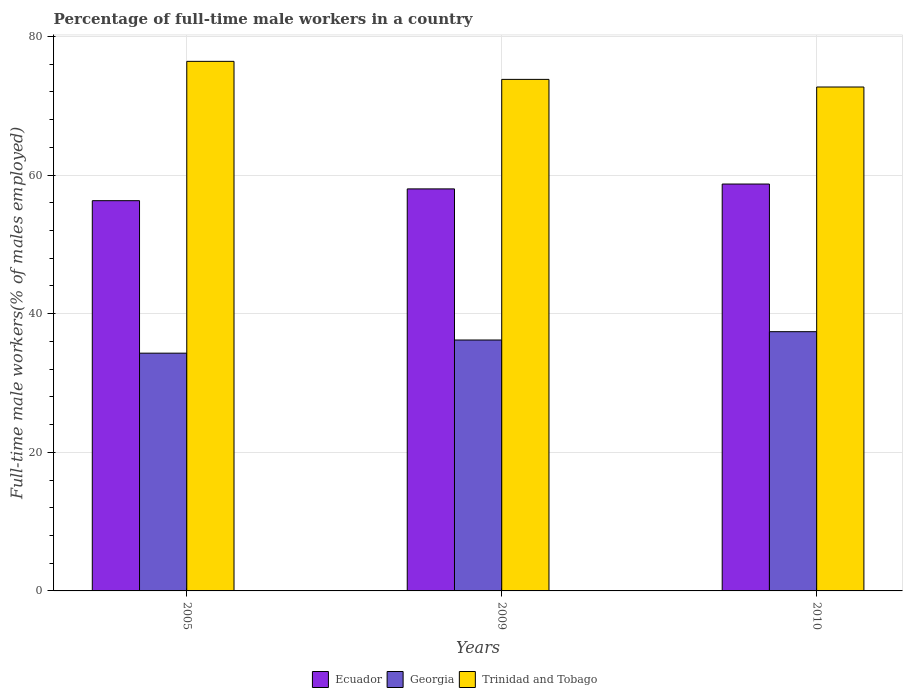How many groups of bars are there?
Your response must be concise. 3. Are the number of bars per tick equal to the number of legend labels?
Your answer should be compact. Yes. Are the number of bars on each tick of the X-axis equal?
Provide a succinct answer. Yes. In how many cases, is the number of bars for a given year not equal to the number of legend labels?
Your answer should be compact. 0. What is the percentage of full-time male workers in Trinidad and Tobago in 2009?
Provide a short and direct response. 73.8. Across all years, what is the maximum percentage of full-time male workers in Georgia?
Keep it short and to the point. 37.4. Across all years, what is the minimum percentage of full-time male workers in Trinidad and Tobago?
Your response must be concise. 72.7. In which year was the percentage of full-time male workers in Georgia minimum?
Your answer should be compact. 2005. What is the total percentage of full-time male workers in Ecuador in the graph?
Provide a short and direct response. 173. What is the difference between the percentage of full-time male workers in Trinidad and Tobago in 2009 and that in 2010?
Your answer should be compact. 1.1. What is the difference between the percentage of full-time male workers in Georgia in 2005 and the percentage of full-time male workers in Trinidad and Tobago in 2009?
Your answer should be very brief. -39.5. What is the average percentage of full-time male workers in Ecuador per year?
Offer a terse response. 57.67. In the year 2009, what is the difference between the percentage of full-time male workers in Trinidad and Tobago and percentage of full-time male workers in Georgia?
Provide a short and direct response. 37.6. What is the ratio of the percentage of full-time male workers in Georgia in 2005 to that in 2010?
Your answer should be compact. 0.92. Is the percentage of full-time male workers in Trinidad and Tobago in 2005 less than that in 2009?
Keep it short and to the point. No. Is the difference between the percentage of full-time male workers in Trinidad and Tobago in 2005 and 2009 greater than the difference between the percentage of full-time male workers in Georgia in 2005 and 2009?
Provide a short and direct response. Yes. What is the difference between the highest and the second highest percentage of full-time male workers in Ecuador?
Give a very brief answer. 0.7. What is the difference between the highest and the lowest percentage of full-time male workers in Georgia?
Keep it short and to the point. 3.1. What does the 2nd bar from the left in 2009 represents?
Make the answer very short. Georgia. What does the 1st bar from the right in 2010 represents?
Offer a terse response. Trinidad and Tobago. Is it the case that in every year, the sum of the percentage of full-time male workers in Trinidad and Tobago and percentage of full-time male workers in Ecuador is greater than the percentage of full-time male workers in Georgia?
Keep it short and to the point. Yes. Are the values on the major ticks of Y-axis written in scientific E-notation?
Give a very brief answer. No. Does the graph contain any zero values?
Provide a succinct answer. No. Does the graph contain grids?
Your response must be concise. Yes. Where does the legend appear in the graph?
Offer a very short reply. Bottom center. How many legend labels are there?
Make the answer very short. 3. What is the title of the graph?
Give a very brief answer. Percentage of full-time male workers in a country. What is the label or title of the Y-axis?
Offer a terse response. Full-time male workers(% of males employed). What is the Full-time male workers(% of males employed) of Ecuador in 2005?
Provide a short and direct response. 56.3. What is the Full-time male workers(% of males employed) in Georgia in 2005?
Offer a terse response. 34.3. What is the Full-time male workers(% of males employed) of Trinidad and Tobago in 2005?
Make the answer very short. 76.4. What is the Full-time male workers(% of males employed) of Georgia in 2009?
Your answer should be very brief. 36.2. What is the Full-time male workers(% of males employed) of Trinidad and Tobago in 2009?
Give a very brief answer. 73.8. What is the Full-time male workers(% of males employed) in Ecuador in 2010?
Your answer should be compact. 58.7. What is the Full-time male workers(% of males employed) in Georgia in 2010?
Your answer should be very brief. 37.4. What is the Full-time male workers(% of males employed) in Trinidad and Tobago in 2010?
Provide a short and direct response. 72.7. Across all years, what is the maximum Full-time male workers(% of males employed) in Ecuador?
Ensure brevity in your answer.  58.7. Across all years, what is the maximum Full-time male workers(% of males employed) of Georgia?
Offer a very short reply. 37.4. Across all years, what is the maximum Full-time male workers(% of males employed) in Trinidad and Tobago?
Provide a succinct answer. 76.4. Across all years, what is the minimum Full-time male workers(% of males employed) of Ecuador?
Offer a terse response. 56.3. Across all years, what is the minimum Full-time male workers(% of males employed) in Georgia?
Keep it short and to the point. 34.3. Across all years, what is the minimum Full-time male workers(% of males employed) in Trinidad and Tobago?
Give a very brief answer. 72.7. What is the total Full-time male workers(% of males employed) in Ecuador in the graph?
Offer a very short reply. 173. What is the total Full-time male workers(% of males employed) of Georgia in the graph?
Ensure brevity in your answer.  107.9. What is the total Full-time male workers(% of males employed) in Trinidad and Tobago in the graph?
Provide a short and direct response. 222.9. What is the difference between the Full-time male workers(% of males employed) of Ecuador in 2005 and that in 2009?
Keep it short and to the point. -1.7. What is the difference between the Full-time male workers(% of males employed) in Ecuador in 2005 and that in 2010?
Your answer should be compact. -2.4. What is the difference between the Full-time male workers(% of males employed) in Trinidad and Tobago in 2005 and that in 2010?
Offer a terse response. 3.7. What is the difference between the Full-time male workers(% of males employed) of Trinidad and Tobago in 2009 and that in 2010?
Give a very brief answer. 1.1. What is the difference between the Full-time male workers(% of males employed) in Ecuador in 2005 and the Full-time male workers(% of males employed) in Georgia in 2009?
Keep it short and to the point. 20.1. What is the difference between the Full-time male workers(% of males employed) in Ecuador in 2005 and the Full-time male workers(% of males employed) in Trinidad and Tobago in 2009?
Your answer should be very brief. -17.5. What is the difference between the Full-time male workers(% of males employed) of Georgia in 2005 and the Full-time male workers(% of males employed) of Trinidad and Tobago in 2009?
Your answer should be compact. -39.5. What is the difference between the Full-time male workers(% of males employed) in Ecuador in 2005 and the Full-time male workers(% of males employed) in Trinidad and Tobago in 2010?
Provide a short and direct response. -16.4. What is the difference between the Full-time male workers(% of males employed) in Georgia in 2005 and the Full-time male workers(% of males employed) in Trinidad and Tobago in 2010?
Ensure brevity in your answer.  -38.4. What is the difference between the Full-time male workers(% of males employed) of Ecuador in 2009 and the Full-time male workers(% of males employed) of Georgia in 2010?
Your response must be concise. 20.6. What is the difference between the Full-time male workers(% of males employed) of Ecuador in 2009 and the Full-time male workers(% of males employed) of Trinidad and Tobago in 2010?
Offer a terse response. -14.7. What is the difference between the Full-time male workers(% of males employed) of Georgia in 2009 and the Full-time male workers(% of males employed) of Trinidad and Tobago in 2010?
Your response must be concise. -36.5. What is the average Full-time male workers(% of males employed) of Ecuador per year?
Your answer should be compact. 57.67. What is the average Full-time male workers(% of males employed) of Georgia per year?
Give a very brief answer. 35.97. What is the average Full-time male workers(% of males employed) of Trinidad and Tobago per year?
Your answer should be very brief. 74.3. In the year 2005, what is the difference between the Full-time male workers(% of males employed) of Ecuador and Full-time male workers(% of males employed) of Trinidad and Tobago?
Provide a short and direct response. -20.1. In the year 2005, what is the difference between the Full-time male workers(% of males employed) of Georgia and Full-time male workers(% of males employed) of Trinidad and Tobago?
Provide a succinct answer. -42.1. In the year 2009, what is the difference between the Full-time male workers(% of males employed) of Ecuador and Full-time male workers(% of males employed) of Georgia?
Your answer should be very brief. 21.8. In the year 2009, what is the difference between the Full-time male workers(% of males employed) in Ecuador and Full-time male workers(% of males employed) in Trinidad and Tobago?
Provide a succinct answer. -15.8. In the year 2009, what is the difference between the Full-time male workers(% of males employed) in Georgia and Full-time male workers(% of males employed) in Trinidad and Tobago?
Give a very brief answer. -37.6. In the year 2010, what is the difference between the Full-time male workers(% of males employed) in Ecuador and Full-time male workers(% of males employed) in Georgia?
Ensure brevity in your answer.  21.3. In the year 2010, what is the difference between the Full-time male workers(% of males employed) in Ecuador and Full-time male workers(% of males employed) in Trinidad and Tobago?
Your answer should be compact. -14. In the year 2010, what is the difference between the Full-time male workers(% of males employed) in Georgia and Full-time male workers(% of males employed) in Trinidad and Tobago?
Your answer should be very brief. -35.3. What is the ratio of the Full-time male workers(% of males employed) of Ecuador in 2005 to that in 2009?
Offer a terse response. 0.97. What is the ratio of the Full-time male workers(% of males employed) of Georgia in 2005 to that in 2009?
Provide a succinct answer. 0.95. What is the ratio of the Full-time male workers(% of males employed) in Trinidad and Tobago in 2005 to that in 2009?
Provide a short and direct response. 1.04. What is the ratio of the Full-time male workers(% of males employed) of Ecuador in 2005 to that in 2010?
Offer a very short reply. 0.96. What is the ratio of the Full-time male workers(% of males employed) in Georgia in 2005 to that in 2010?
Offer a very short reply. 0.92. What is the ratio of the Full-time male workers(% of males employed) of Trinidad and Tobago in 2005 to that in 2010?
Provide a succinct answer. 1.05. What is the ratio of the Full-time male workers(% of males employed) of Georgia in 2009 to that in 2010?
Your response must be concise. 0.97. What is the ratio of the Full-time male workers(% of males employed) in Trinidad and Tobago in 2009 to that in 2010?
Make the answer very short. 1.02. What is the difference between the highest and the second highest Full-time male workers(% of males employed) in Ecuador?
Your answer should be very brief. 0.7. What is the difference between the highest and the lowest Full-time male workers(% of males employed) of Georgia?
Offer a very short reply. 3.1. 